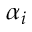Convert formula to latex. <formula><loc_0><loc_0><loc_500><loc_500>\alpha _ { i }</formula> 